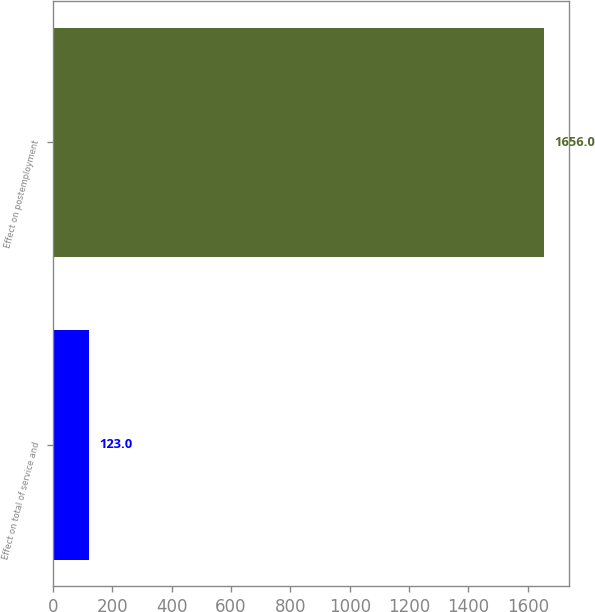<chart> <loc_0><loc_0><loc_500><loc_500><bar_chart><fcel>Effect on total of service and<fcel>Effect on postemployment<nl><fcel>123<fcel>1656<nl></chart> 